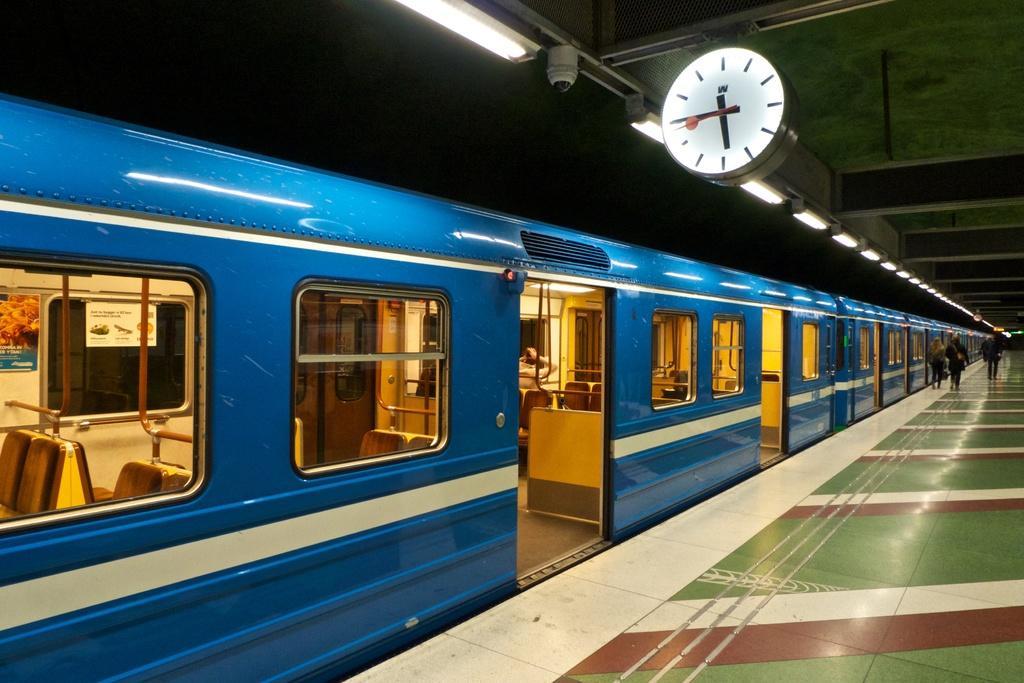In one or two sentences, can you explain what this image depicts? To the right bottom of the image there is a platform with green and red painting. And to the left side of the image there is a blue train with windows. Inside the train there are rods, seats and posters. And to the right top corner of the image there is a roof with clock and also there are rods. 